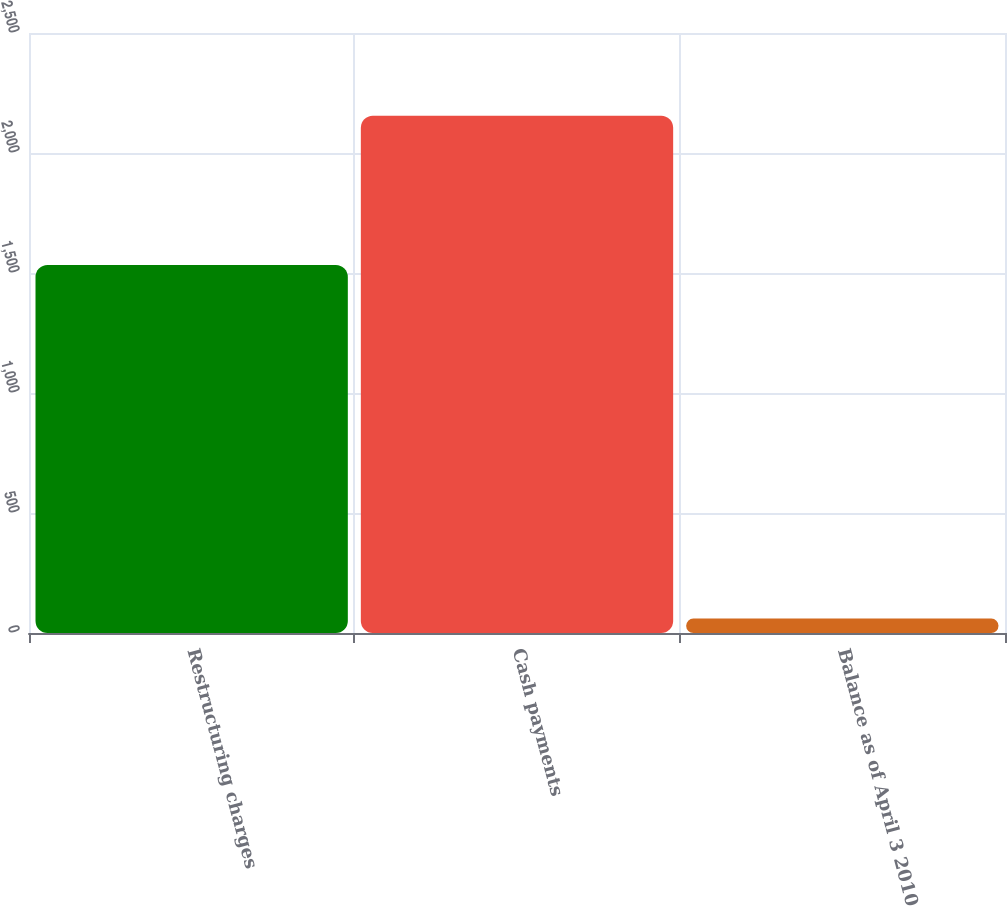Convert chart. <chart><loc_0><loc_0><loc_500><loc_500><bar_chart><fcel>Restructuring charges<fcel>Cash payments<fcel>Balance as of April 3 2010<nl><fcel>1533<fcel>2155<fcel>60<nl></chart> 